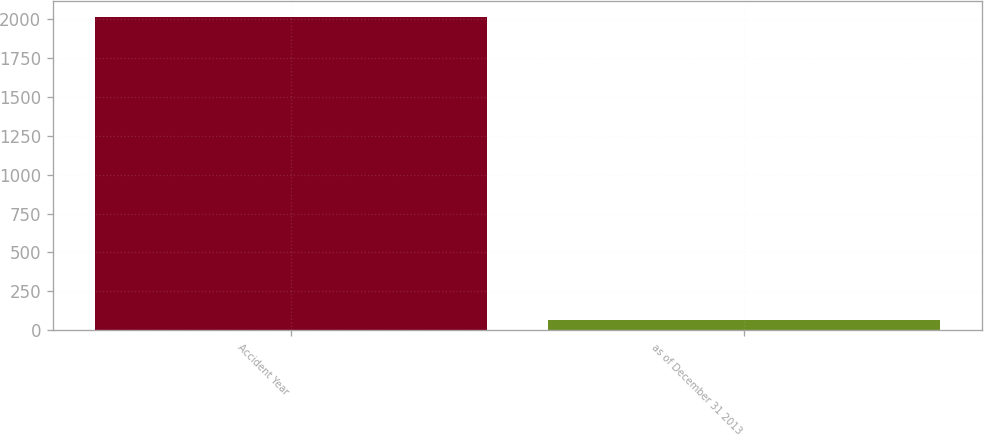<chart> <loc_0><loc_0><loc_500><loc_500><bar_chart><fcel>Accident Year<fcel>as of December 31 2013<nl><fcel>2012<fcel>65.9<nl></chart> 